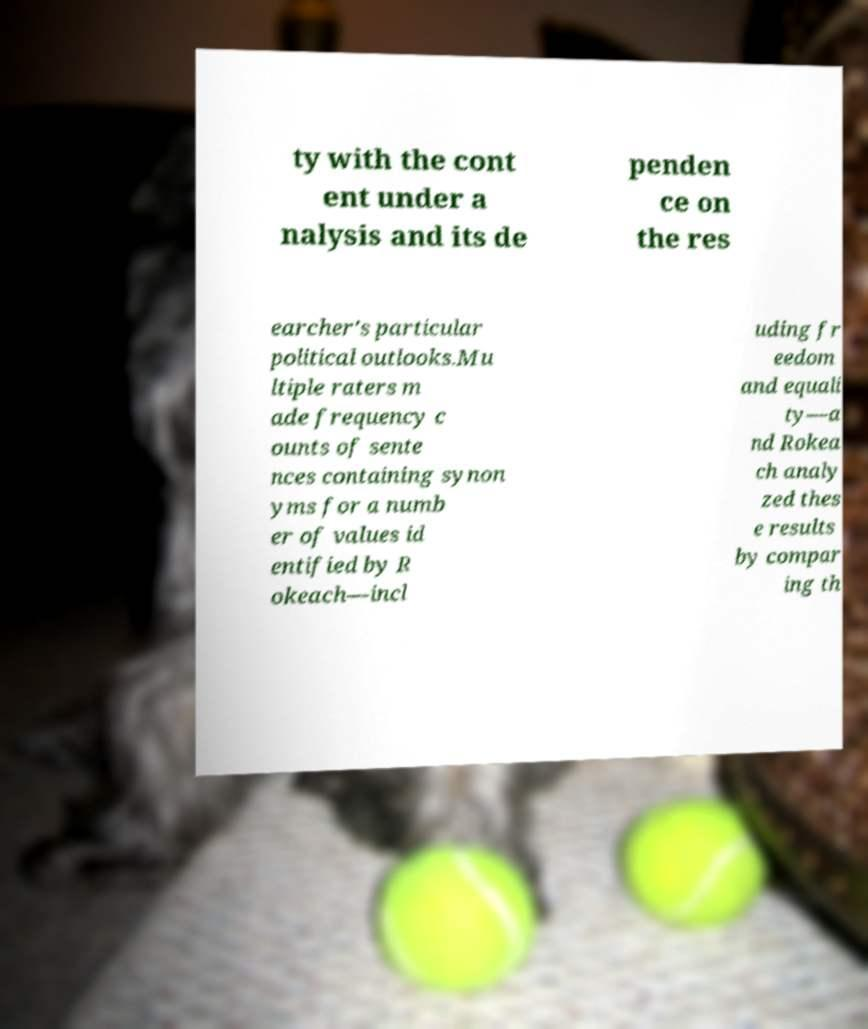For documentation purposes, I need the text within this image transcribed. Could you provide that? ty with the cont ent under a nalysis and its de penden ce on the res earcher's particular political outlooks.Mu ltiple raters m ade frequency c ounts of sente nces containing synon yms for a numb er of values id entified by R okeach—incl uding fr eedom and equali ty—a nd Rokea ch analy zed thes e results by compar ing th 